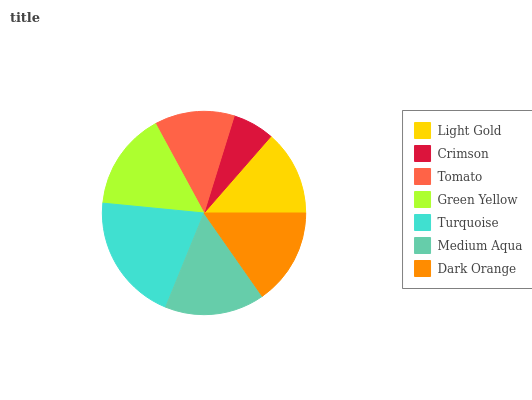Is Crimson the minimum?
Answer yes or no. Yes. Is Turquoise the maximum?
Answer yes or no. Yes. Is Tomato the minimum?
Answer yes or no. No. Is Tomato the maximum?
Answer yes or no. No. Is Tomato greater than Crimson?
Answer yes or no. Yes. Is Crimson less than Tomato?
Answer yes or no. Yes. Is Crimson greater than Tomato?
Answer yes or no. No. Is Tomato less than Crimson?
Answer yes or no. No. Is Dark Orange the high median?
Answer yes or no. Yes. Is Dark Orange the low median?
Answer yes or no. Yes. Is Tomato the high median?
Answer yes or no. No. Is Crimson the low median?
Answer yes or no. No. 